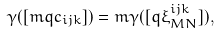<formula> <loc_0><loc_0><loc_500><loc_500>\gamma ( [ m q c _ { i j k } ] ) = m \gamma ( [ q \xi _ { M N } ^ { i j k } ] ) ,</formula> 